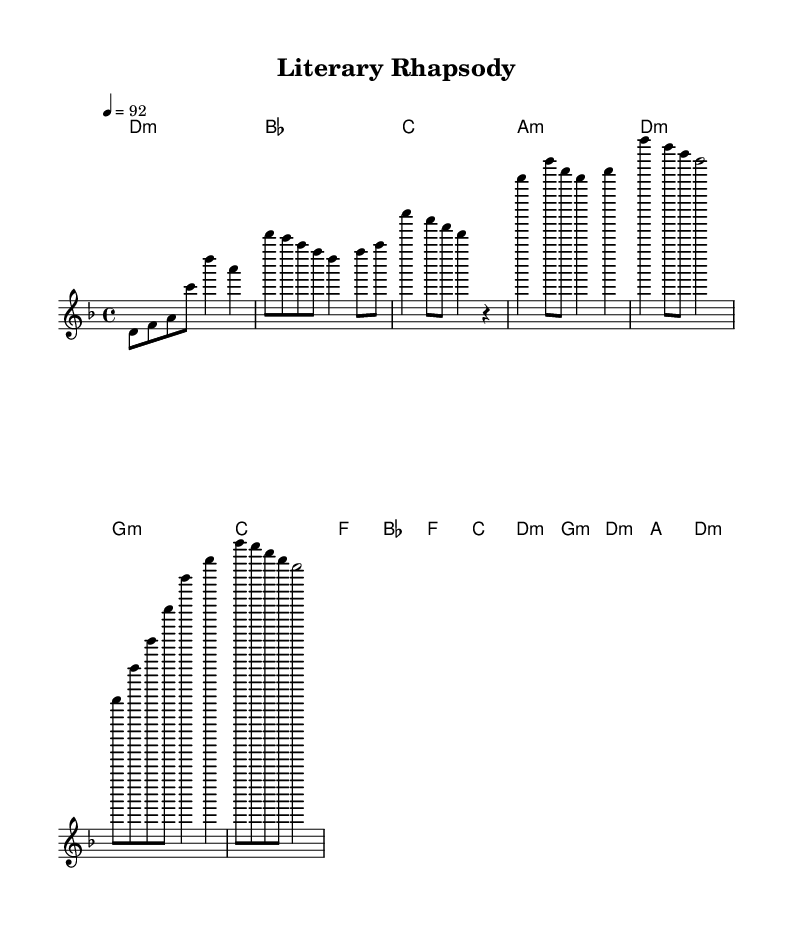What is the key signature of this music? The key signature is D minor, which has one flat. This can be determined by looking at the key indicated at the beginning of the score.
Answer: D minor What is the time signature of this music? The time signature is 4/4. This can be confirmed by the notation placed at the beginning of the score, which indicates that there are four beats per measure.
Answer: 4/4 What is the tempo marking for this piece? The tempo marking is 92, as indicated at the beginning of the score, suggesting a moderate pace.
Answer: 92 How many distinct sections are in the music? There are four distinct sections: Intro, Verse, Chorus, and Bridge. This can be seen by identifying the grouping of measures labeled in each section of the sheet music.
Answer: Four What harmony follows the Chorus section? The harmony following the Chorus is G minor. By analyzing the chord changes, the sequence reveals G minor is played after the previously indicated chords of the Chorus.
Answer: G minor Which chord is sustained for the longest duration in the Intro section? The chord D minor is sustained for a whole measure in the Intro section, while the other chords have shorter durations. This is seen by examining the chord notation in the Intro line of harmony.
Answer: D minor What is the ending chord of the Bridge? The ending chord of the Bridge section is D minor. This is determined by looking at the final harmony indicated in the Bridge segment.
Answer: D minor 